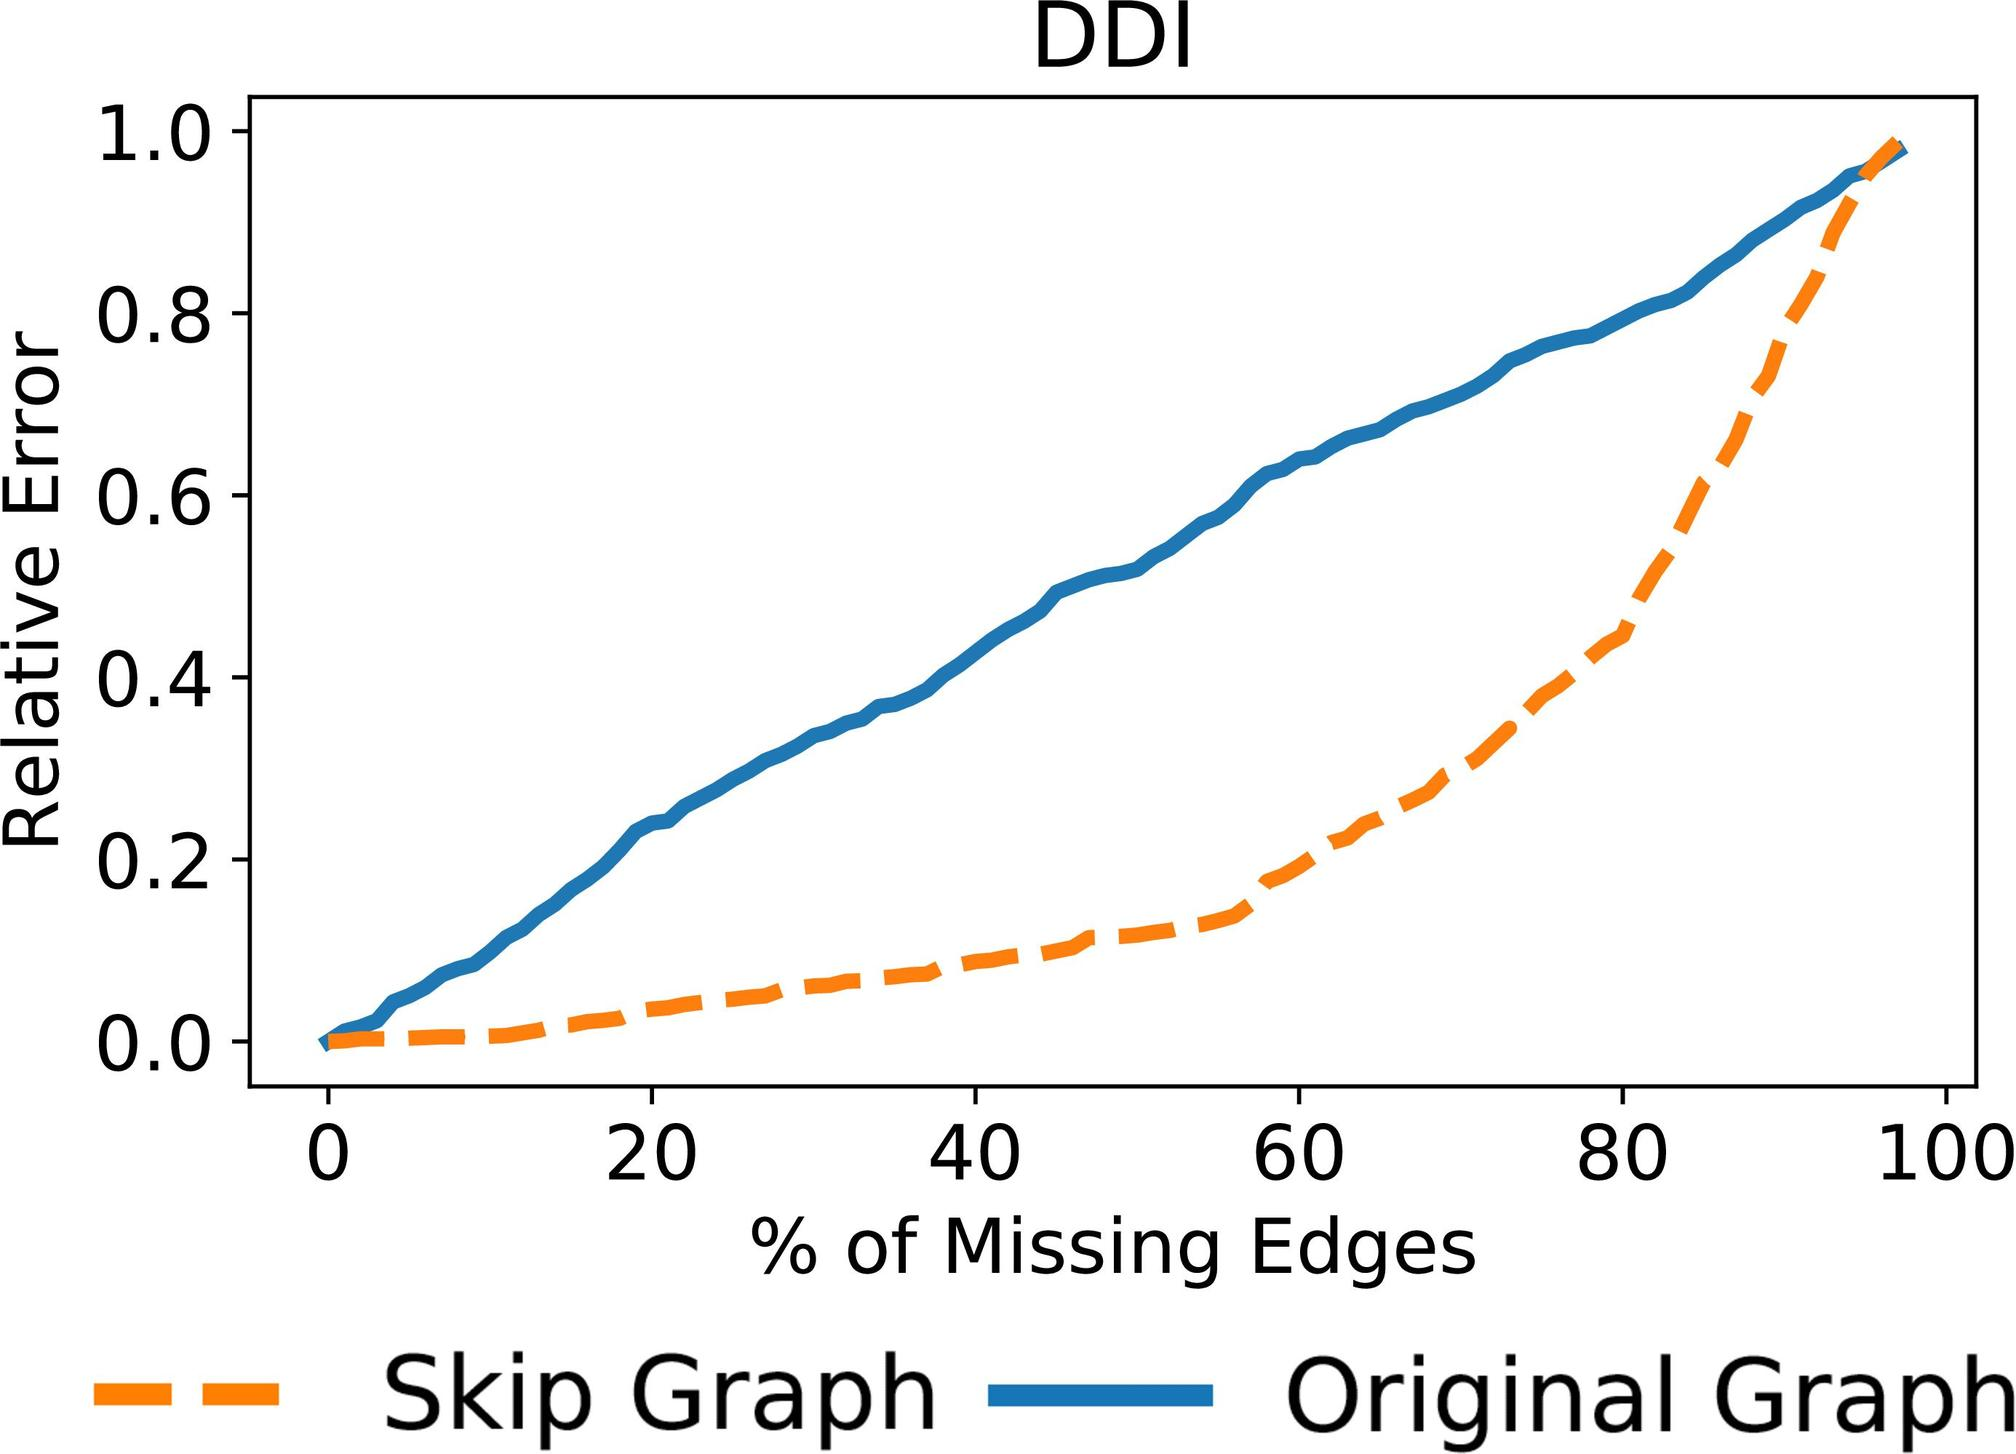Based on the graph, how does the relative error change as the percentage of missing edges increases for the Skip Graph? A. It decreases steadily. B. It remains constant. C. It increases steadily. D. It increases and then decreases. The dashed orange line representing the Skip Graph in the provided graph shows a continuous increase in relative error as the percentage of missing edges increases. This indicates that as more edges are omitted from the Skip Graph, its capability to accurately replicate or function decreases, making it less reliable. This trend underscores the importance of edge integrity in graph-based data structures, particularly in methods like Skip Graphs where node connectivity is crucial for performance. The correct answer is C, the relative error increases steadily. 